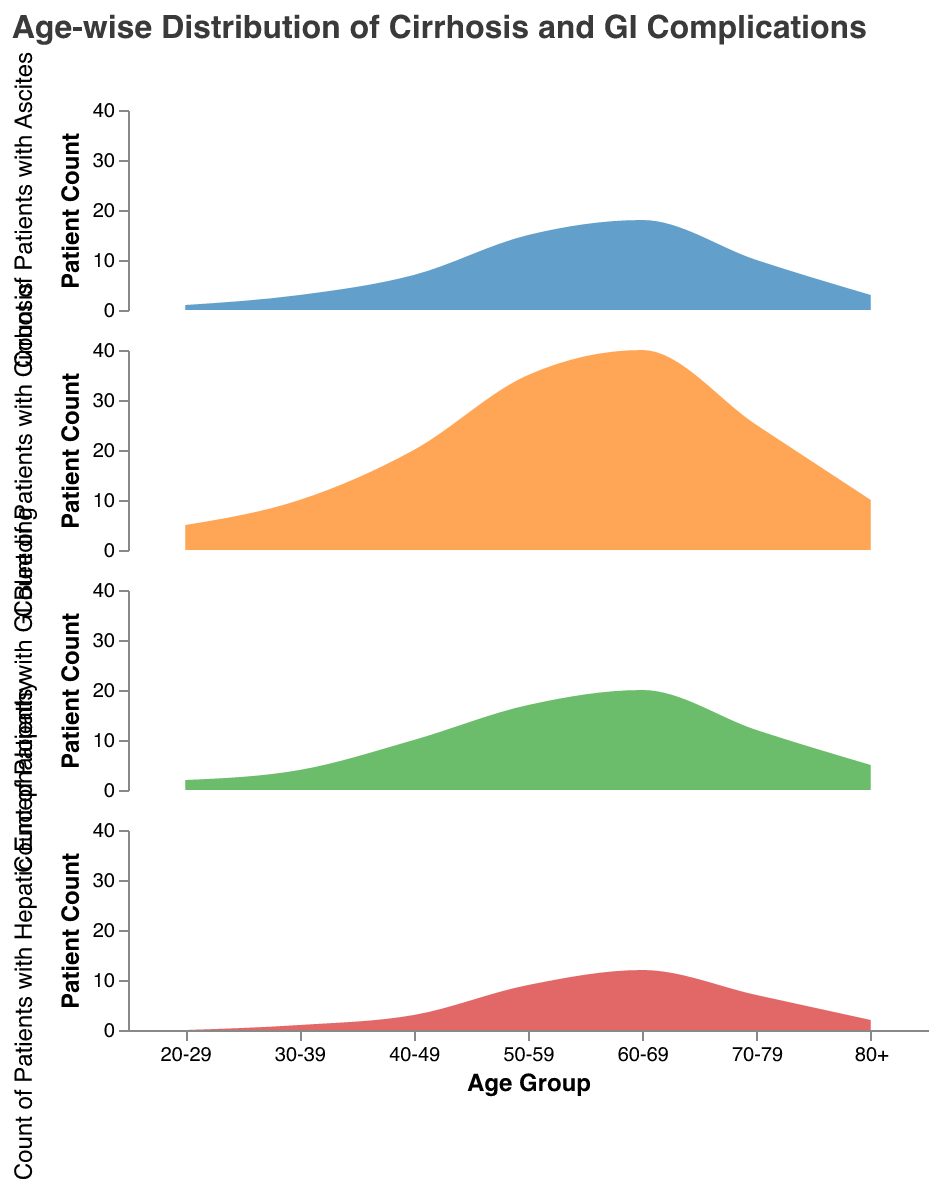which age group has the highest count of patients with cirrhosis? The first subplot shows the "Count of Patients with Cirrhosis" density plot. Comparing the peaks of the plot, the 60-69 age group has the highest peak.
Answer: 60-69 which age group has the lowest count of patients with GI bleeding? The second subplot shows the "Count of Patients with GI Bleeding" density plot. The plot shows that the 20-29 age group has the lowest peak.
Answer: 20-29 what is the sum of patients with hepatic encephalopathy in the 50-59 and 60-69 age groups? From the data, the counts of patients with hepatic encephalopathy in the 50-59 and 60-69 age groups are 9 and 12, respectively. Summing them gives 9 + 12 = 21.
Answer: 21 how many more patients with ascites are there in the 60-69 age group compared to the 20-29 age group? From the data, there are 18 patients with ascites in the 60-69 age group and 1 patient in the 20-29 age group. The difference is 18 - 1 = 17.
Answer: 17 which gastrointestinal complication has the highest count in the 70-79 age group? For the 70-79 age group, there are 12 patients with GI bleeding, 10 patients with ascites, and 7 patients with hepatic encephalopathy. GI bleeding has the highest count.
Answer: GI bleeding which complication shows a consistent increase in patient count with age, peaking at 60-69? Observing all subplots, the "Count of Patients with Ascites" shows a consistent increase, peaking at 60-69.
Answer: ascites which age group has a notable decline in the number of patients with cirrhosis after reaching the peak? The "Count of Patients with Cirrhosis" density plot peaks at 60-69 and declines notably in the 70-79 age group.
Answer: 70-79 what is the average count of patients with GI bleeding across all age groups? Summing the counts of patients with GI bleeding across all age groups: 2 + 4 + 10 + 17 + 20 + 12 + 5 = 70. There are 7 age groups, so the average is 70/7 = 10.
Answer: 10 which age groups have the same number of patients with hepatic encephalopathy? Both the 30-39 and 70-79 age groups have 1 and 7 patients with hepatic encephalopathy, respectively.
Answer: 30-39, 70-79 